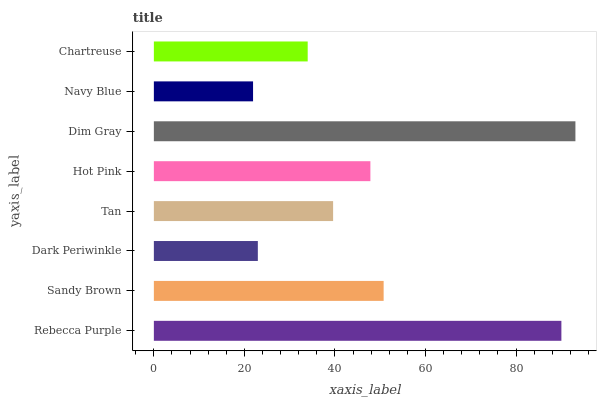Is Navy Blue the minimum?
Answer yes or no. Yes. Is Dim Gray the maximum?
Answer yes or no. Yes. Is Sandy Brown the minimum?
Answer yes or no. No. Is Sandy Brown the maximum?
Answer yes or no. No. Is Rebecca Purple greater than Sandy Brown?
Answer yes or no. Yes. Is Sandy Brown less than Rebecca Purple?
Answer yes or no. Yes. Is Sandy Brown greater than Rebecca Purple?
Answer yes or no. No. Is Rebecca Purple less than Sandy Brown?
Answer yes or no. No. Is Hot Pink the high median?
Answer yes or no. Yes. Is Tan the low median?
Answer yes or no. Yes. Is Dim Gray the high median?
Answer yes or no. No. Is Hot Pink the low median?
Answer yes or no. No. 